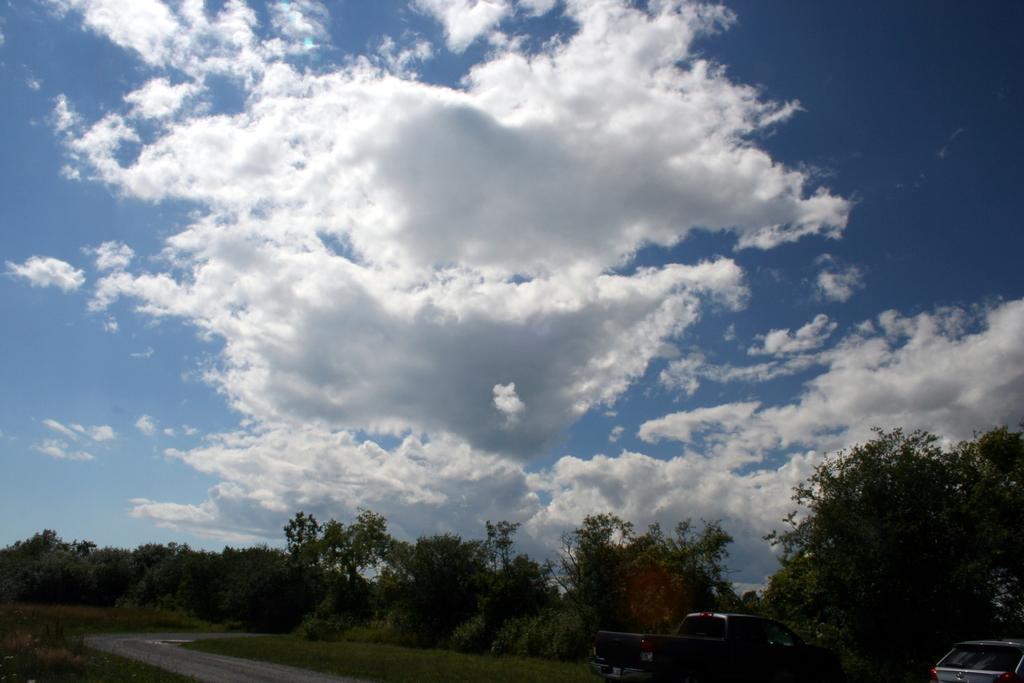Please provide a concise description of this image. In this picture we can observe a road. There is some grass on the ground. We can observe two vehicles. In the background there are trees and a sky with clouds. 